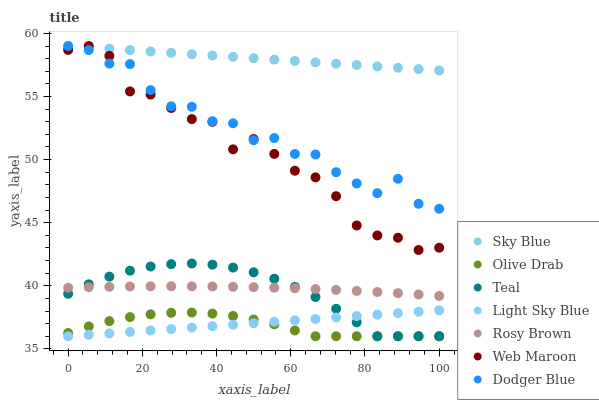Does Olive Drab have the minimum area under the curve?
Answer yes or no. Yes. Does Sky Blue have the maximum area under the curve?
Answer yes or no. Yes. Does Web Maroon have the minimum area under the curve?
Answer yes or no. No. Does Web Maroon have the maximum area under the curve?
Answer yes or no. No. Is Light Sky Blue the smoothest?
Answer yes or no. Yes. Is Dodger Blue the roughest?
Answer yes or no. Yes. Is Web Maroon the smoothest?
Answer yes or no. No. Is Web Maroon the roughest?
Answer yes or no. No. Does Light Sky Blue have the lowest value?
Answer yes or no. Yes. Does Web Maroon have the lowest value?
Answer yes or no. No. Does Sky Blue have the highest value?
Answer yes or no. Yes. Does Light Sky Blue have the highest value?
Answer yes or no. No. Is Light Sky Blue less than Rosy Brown?
Answer yes or no. Yes. Is Dodger Blue greater than Light Sky Blue?
Answer yes or no. Yes. Does Sky Blue intersect Dodger Blue?
Answer yes or no. Yes. Is Sky Blue less than Dodger Blue?
Answer yes or no. No. Is Sky Blue greater than Dodger Blue?
Answer yes or no. No. Does Light Sky Blue intersect Rosy Brown?
Answer yes or no. No. 